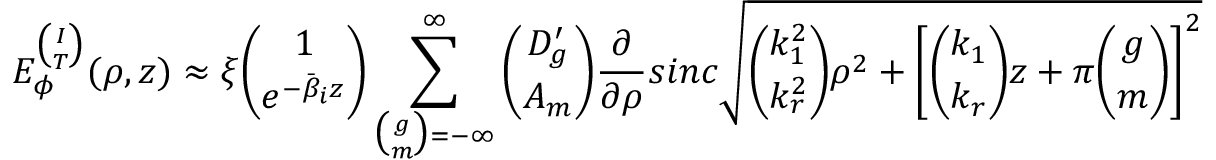<formula> <loc_0><loc_0><loc_500><loc_500>E _ { \phi } ^ { \binom { I } { T } } ( \rho , z ) \approx \xi { \binom { 1 } { e ^ { - \bar { \beta } _ { i } z } } } \sum _ { { \binom { g } { m } } = - \infty } ^ { \infty } { \binom { D _ { g } ^ { \prime } } { A _ { m } } } \frac { \partial } { \partial \rho } \sin c \sqrt { { \binom { k _ { 1 } ^ { 2 } } { k _ { r } ^ { 2 } } } \rho ^ { 2 } + \left [ { \binom { k _ { 1 } } { k _ { r } } } z + \pi { \binom { g } { m } } \right ] ^ { 2 } }</formula> 